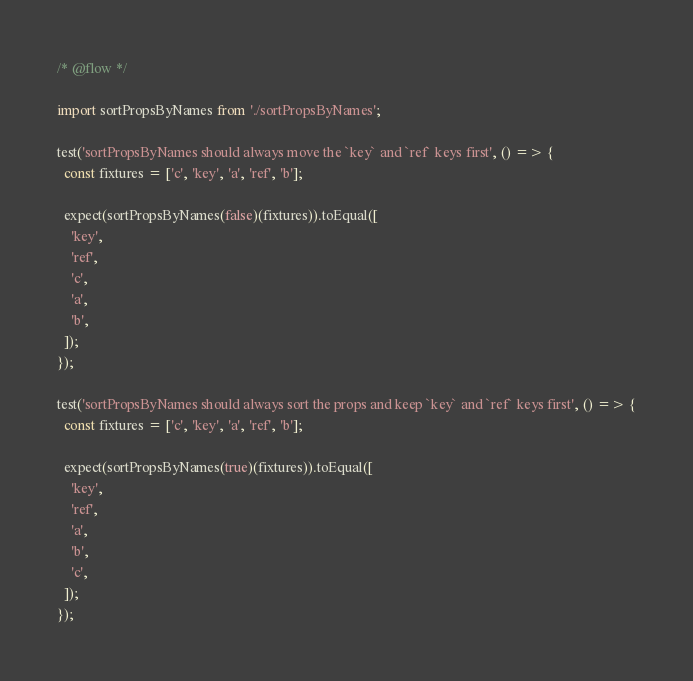Convert code to text. <code><loc_0><loc_0><loc_500><loc_500><_JavaScript_>/* @flow */

import sortPropsByNames from './sortPropsByNames';

test('sortPropsByNames should always move the `key` and `ref` keys first', () => {
  const fixtures = ['c', 'key', 'a', 'ref', 'b'];

  expect(sortPropsByNames(false)(fixtures)).toEqual([
    'key',
    'ref',
    'c',
    'a',
    'b',
  ]);
});

test('sortPropsByNames should always sort the props and keep `key` and `ref` keys first', () => {
  const fixtures = ['c', 'key', 'a', 'ref', 'b'];

  expect(sortPropsByNames(true)(fixtures)).toEqual([
    'key',
    'ref',
    'a',
    'b',
    'c',
  ]);
});
</code> 